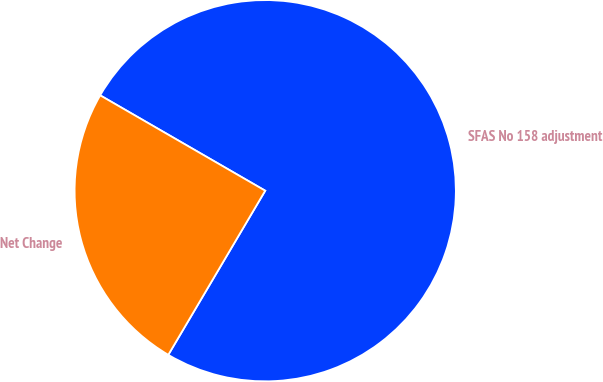<chart> <loc_0><loc_0><loc_500><loc_500><pie_chart><fcel>SFAS No 158 adjustment<fcel>Net Change<nl><fcel>75.15%<fcel>24.85%<nl></chart> 